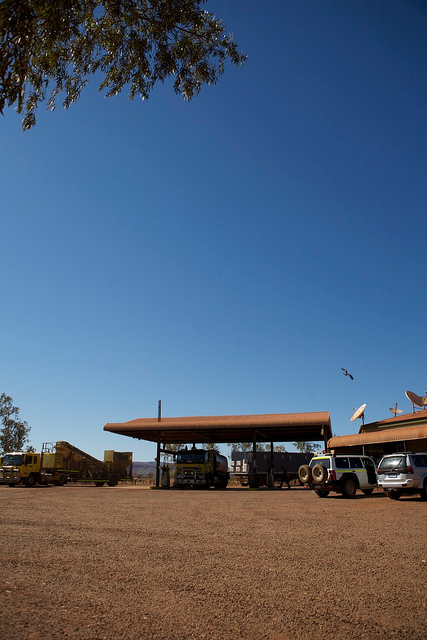<image>Where was this picture taken? It's unknown where this picture was taken. Some may perceive it as outdoors or even a beach but there is no definite answer. Where was this picture taken? It is unanswerable where the picture was taken. There is no picture available. 